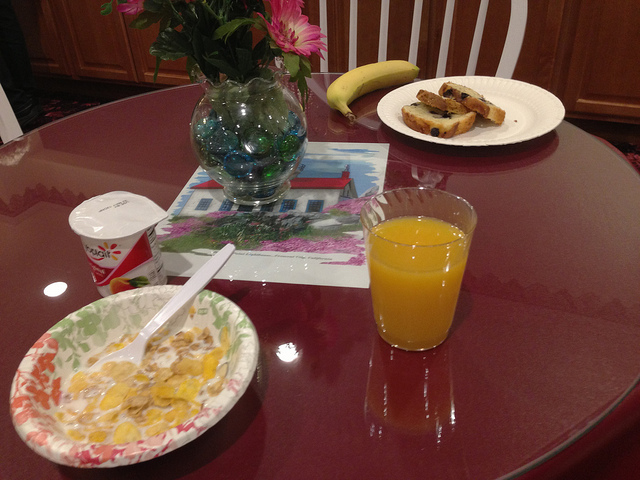Assess the healthiness of the breakfast shown here. What changes could make it healthier? The breakfast on display offers a good mix of carbohydrates and vitamins. For a healthier meal, consider whole-grain toast instead of white bread to increase fiber intake. Additionally, swapping out the butter on the toast for a heart-healthy option like avocado could enhance the nutritional profile. Including a portion of protein, such as low-fat Greek yogurt, would also make for a more balanced breakfast. 